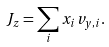<formula> <loc_0><loc_0><loc_500><loc_500>J _ { z } = \sum _ { i } x _ { i } v _ { y , i } .</formula> 